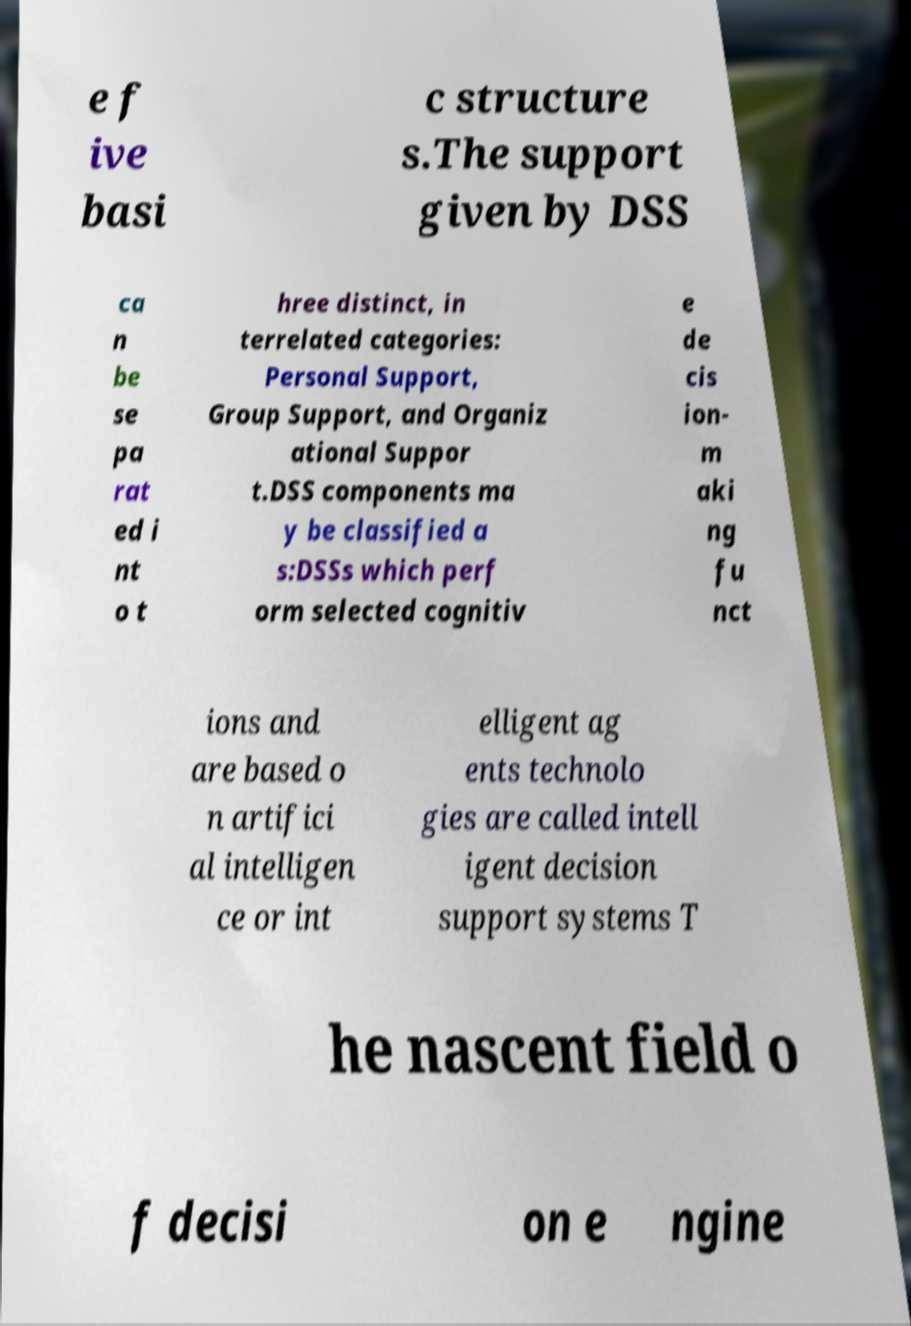What messages or text are displayed in this image? I need them in a readable, typed format. e f ive basi c structure s.The support given by DSS ca n be se pa rat ed i nt o t hree distinct, in terrelated categories: Personal Support, Group Support, and Organiz ational Suppor t.DSS components ma y be classified a s:DSSs which perf orm selected cognitiv e de cis ion- m aki ng fu nct ions and are based o n artifici al intelligen ce or int elligent ag ents technolo gies are called intell igent decision support systems T he nascent field o f decisi on e ngine 